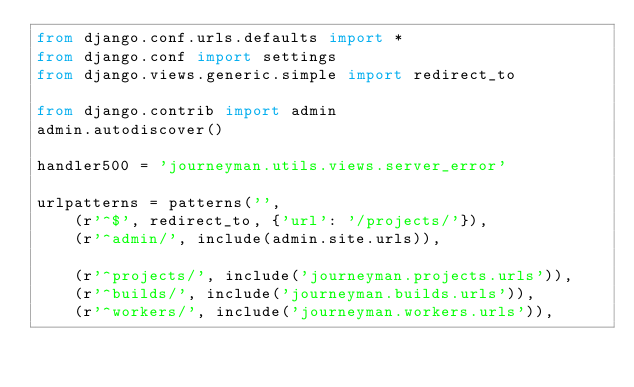Convert code to text. <code><loc_0><loc_0><loc_500><loc_500><_Python_>from django.conf.urls.defaults import *
from django.conf import settings
from django.views.generic.simple import redirect_to

from django.contrib import admin
admin.autodiscover()

handler500 = 'journeyman.utils.views.server_error'

urlpatterns = patterns('',
    (r'^$', redirect_to, {'url': '/projects/'}),
    (r'^admin/', include(admin.site.urls)),

    (r'^projects/', include('journeyman.projects.urls')),
    (r'^builds/', include('journeyman.builds.urls')),
    (r'^workers/', include('journeyman.workers.urls')),</code> 